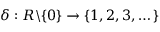<formula> <loc_0><loc_0><loc_500><loc_500>\delta \colon R \mathbb { \ } \{ 0 \} \rightarrow \{ 1 , 2 , 3 , \dots c \}</formula> 